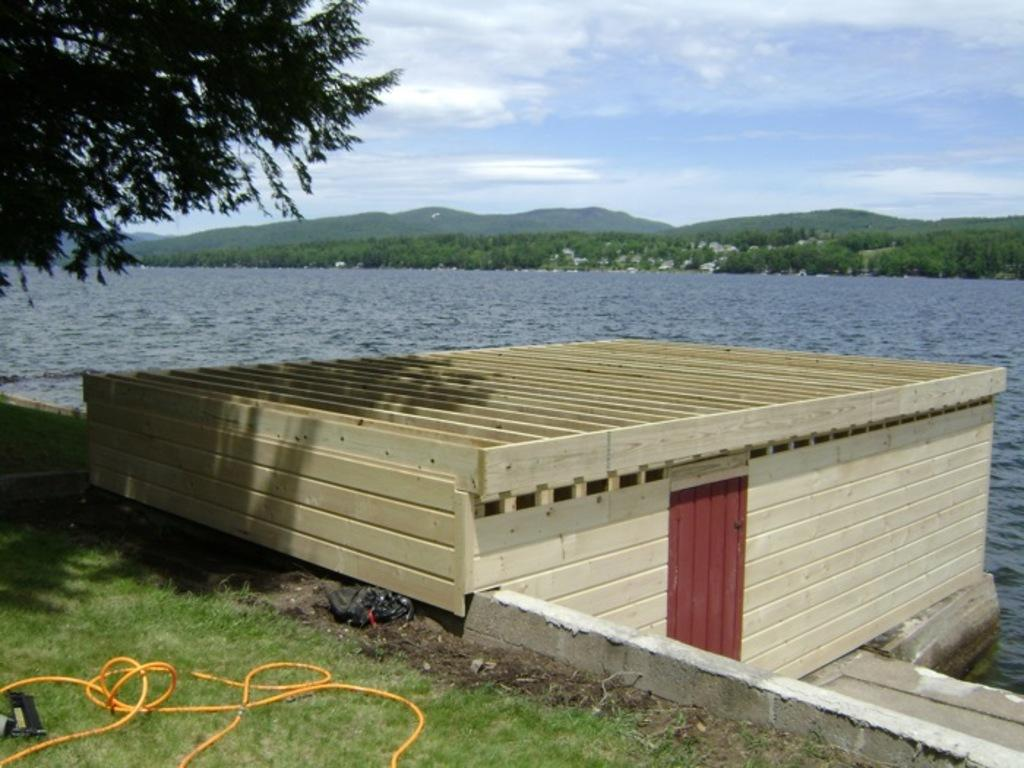What type of house is shown in the image? There is a house made of wooden planks in the image. What can be seen beneath the house? The ground is visible in the image. What type of vegetation is present in the image? Grass, plants, and trees are visible in the image. What natural features can be seen in the background of the image? Mountains are visible in the image. What part of the sky is visible in the image? The sky is visible in the image. What type of powder is being used to clean the alley in the image? There is no alley or powder present in the image. What type of industry can be seen in the image? There is no industry present in the image. 